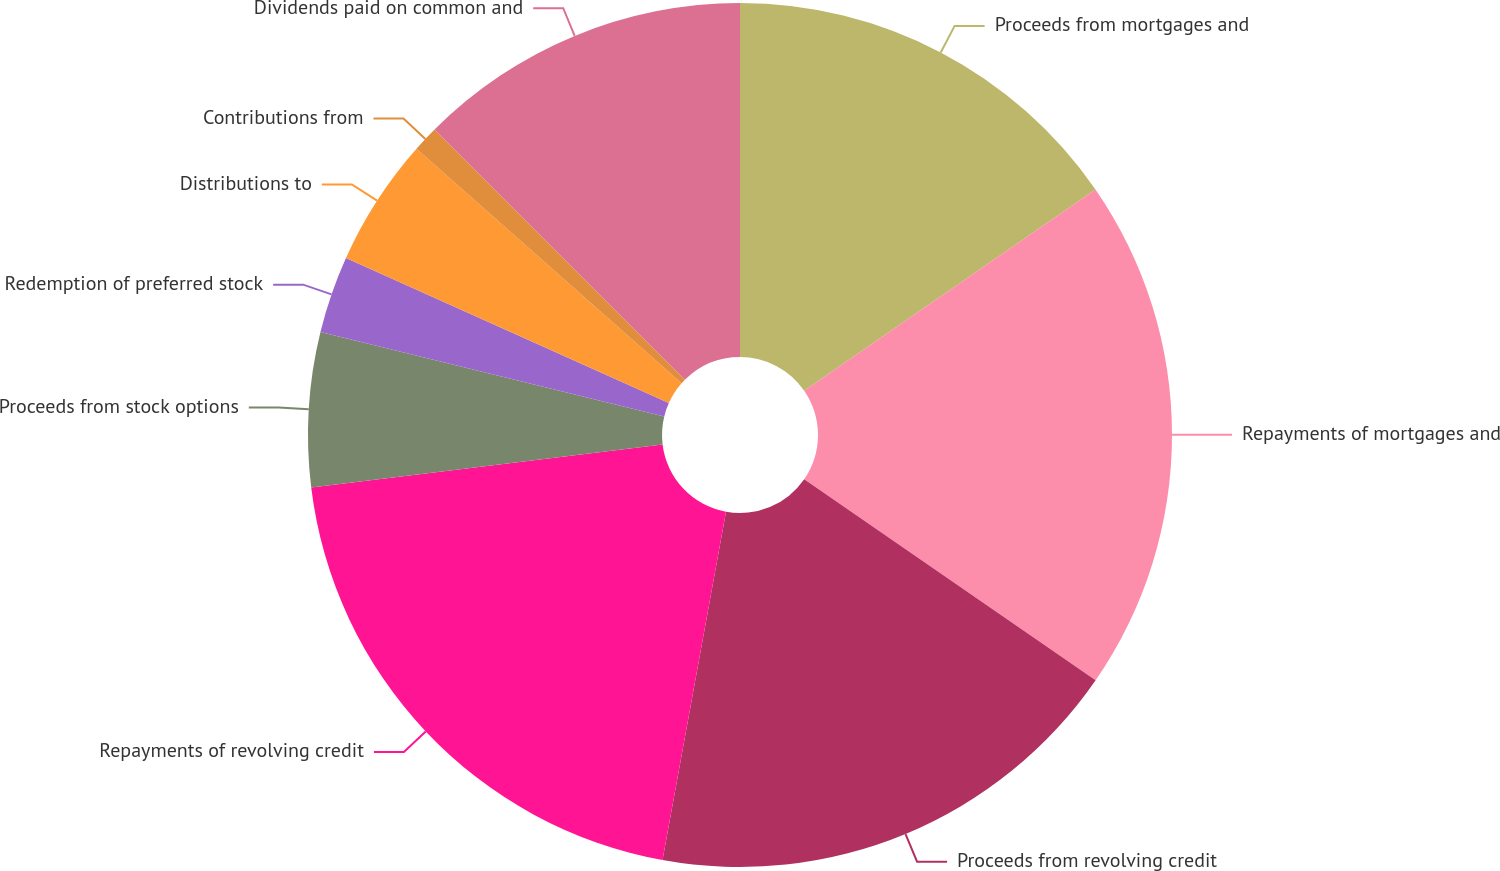Convert chart. <chart><loc_0><loc_0><loc_500><loc_500><pie_chart><fcel>Proceeds from mortgages and<fcel>Repayments of mortgages and<fcel>Proceeds from revolving credit<fcel>Repayments of revolving credit<fcel>Proceeds from stock options<fcel>Redemption of preferred stock<fcel>Distributions to<fcel>Contributions from<fcel>Dividends paid on common and<nl><fcel>15.38%<fcel>19.23%<fcel>18.26%<fcel>20.19%<fcel>5.77%<fcel>2.89%<fcel>4.81%<fcel>0.97%<fcel>12.5%<nl></chart> 